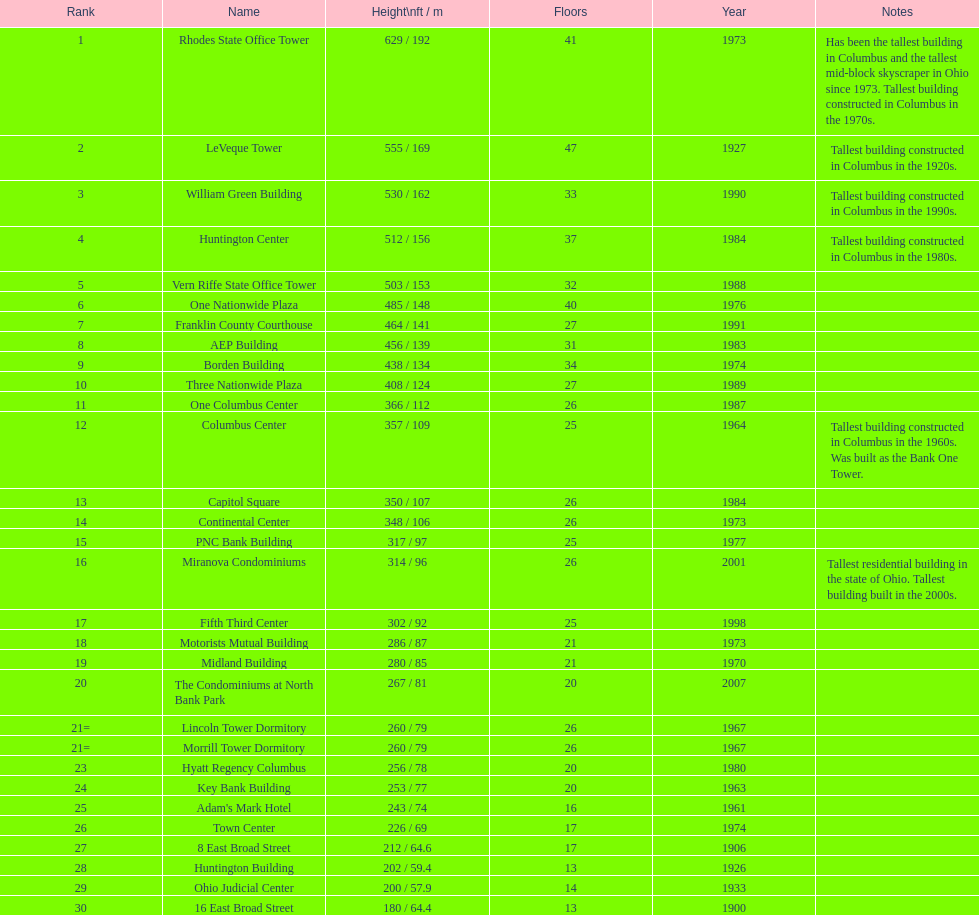Which is higher, the aep building or the one columbus center? AEP Building. 